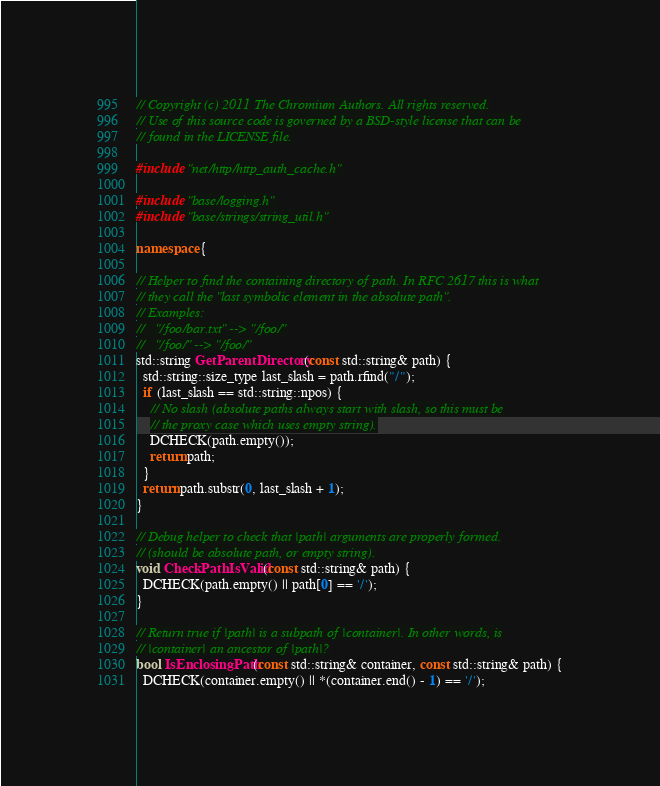<code> <loc_0><loc_0><loc_500><loc_500><_C++_>// Copyright (c) 2011 The Chromium Authors. All rights reserved.
// Use of this source code is governed by a BSD-style license that can be
// found in the LICENSE file.

#include "net/http/http_auth_cache.h"

#include "base/logging.h"
#include "base/strings/string_util.h"

namespace {

// Helper to find the containing directory of path. In RFC 2617 this is what
// they call the "last symbolic element in the absolute path".
// Examples:
//   "/foo/bar.txt" --> "/foo/"
//   "/foo/" --> "/foo/"
std::string GetParentDirectory(const std::string& path) {
  std::string::size_type last_slash = path.rfind("/");
  if (last_slash == std::string::npos) {
    // No slash (absolute paths always start with slash, so this must be
    // the proxy case which uses empty string).
    DCHECK(path.empty());
    return path;
  }
  return path.substr(0, last_slash + 1);
}

// Debug helper to check that |path| arguments are properly formed.
// (should be absolute path, or empty string).
void CheckPathIsValid(const std::string& path) {
  DCHECK(path.empty() || path[0] == '/');
}

// Return true if |path| is a subpath of |container|. In other words, is
// |container| an ancestor of |path|?
bool IsEnclosingPath(const std::string& container, const std::string& path) {
  DCHECK(container.empty() || *(container.end() - 1) == '/');</code> 